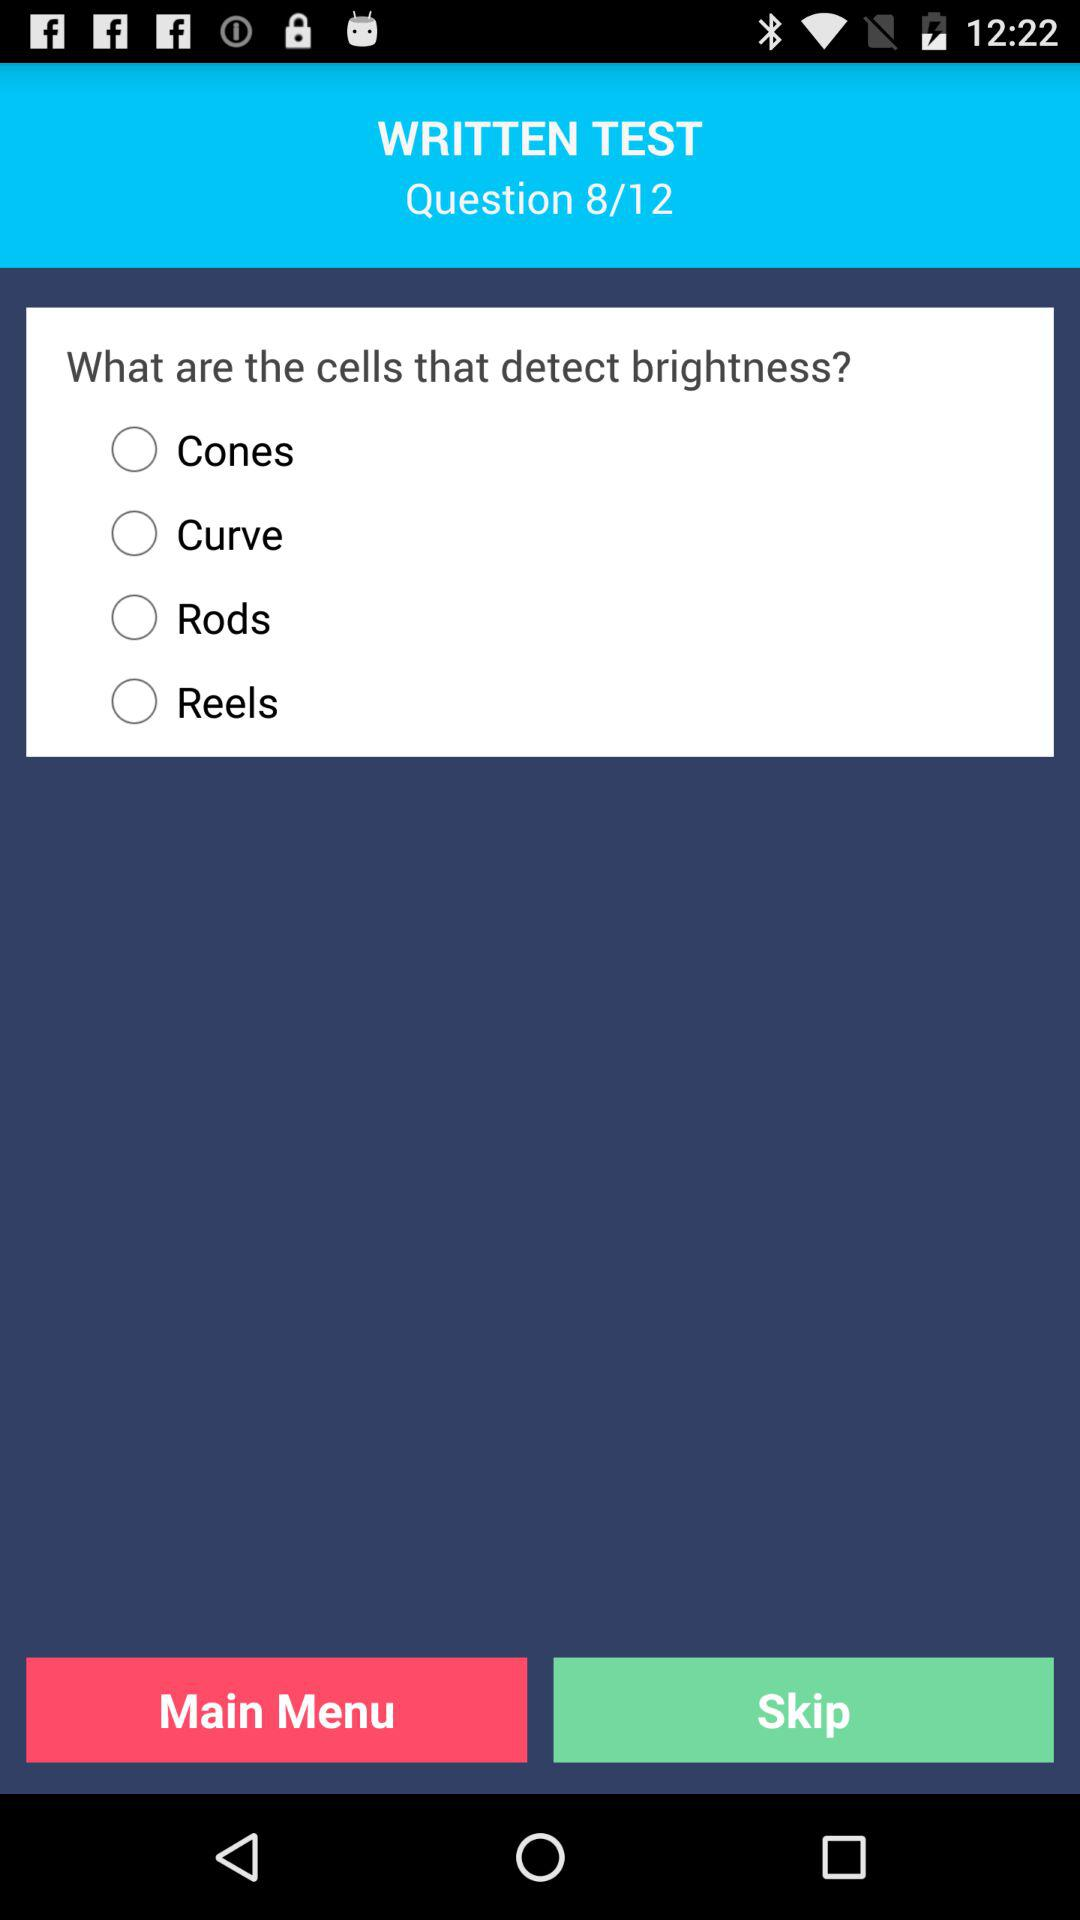How many questions in total are there in the written test? There are 12 questions in total. 